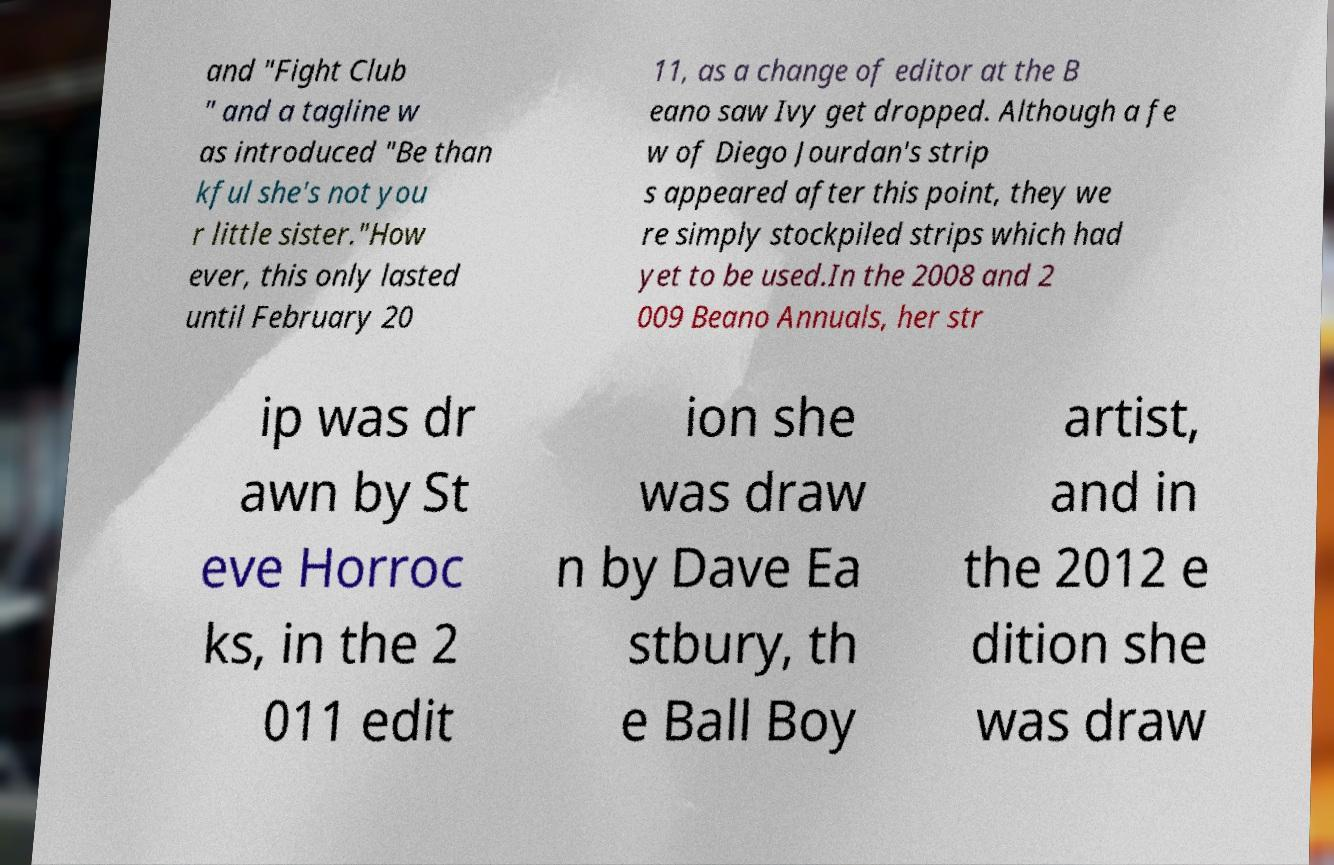What messages or text are displayed in this image? I need them in a readable, typed format. and "Fight Club " and a tagline w as introduced "Be than kful she's not you r little sister."How ever, this only lasted until February 20 11, as a change of editor at the B eano saw Ivy get dropped. Although a fe w of Diego Jourdan's strip s appeared after this point, they we re simply stockpiled strips which had yet to be used.In the 2008 and 2 009 Beano Annuals, her str ip was dr awn by St eve Horroc ks, in the 2 011 edit ion she was draw n by Dave Ea stbury, th e Ball Boy artist, and in the 2012 e dition she was draw 